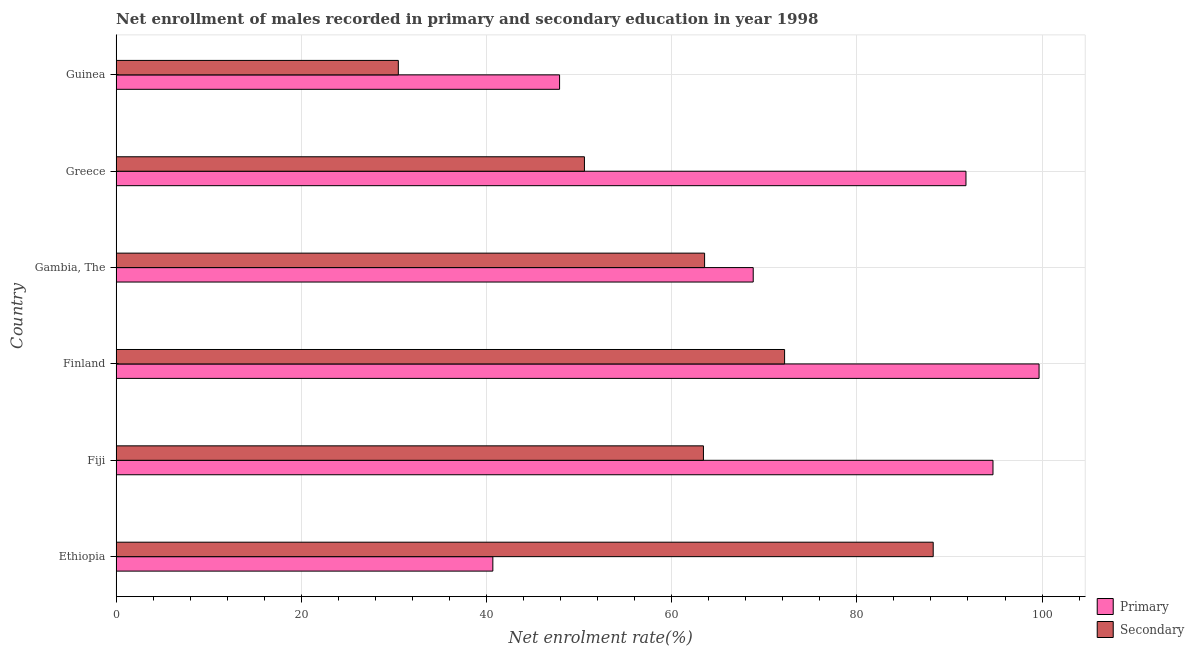How many different coloured bars are there?
Offer a terse response. 2. Are the number of bars on each tick of the Y-axis equal?
Provide a succinct answer. Yes. What is the label of the 4th group of bars from the top?
Provide a succinct answer. Finland. What is the enrollment rate in secondary education in Guinea?
Ensure brevity in your answer.  30.48. Across all countries, what is the maximum enrollment rate in secondary education?
Your response must be concise. 88.24. Across all countries, what is the minimum enrollment rate in secondary education?
Give a very brief answer. 30.48. In which country was the enrollment rate in primary education maximum?
Make the answer very short. Finland. In which country was the enrollment rate in secondary education minimum?
Your answer should be very brief. Guinea. What is the total enrollment rate in secondary education in the graph?
Provide a succinct answer. 368.48. What is the difference between the enrollment rate in primary education in Ethiopia and that in Gambia, The?
Provide a short and direct response. -28.12. What is the difference between the enrollment rate in secondary education in Fiji and the enrollment rate in primary education in Guinea?
Ensure brevity in your answer.  15.54. What is the average enrollment rate in secondary education per country?
Keep it short and to the point. 61.41. What is the difference between the enrollment rate in secondary education and enrollment rate in primary education in Finland?
Provide a succinct answer. -27.48. In how many countries, is the enrollment rate in secondary education greater than 72 %?
Your answer should be very brief. 2. What is the ratio of the enrollment rate in secondary education in Fiji to that in Greece?
Your answer should be compact. 1.25. Is the enrollment rate in primary education in Finland less than that in Greece?
Your response must be concise. No. Is the difference between the enrollment rate in secondary education in Finland and Gambia, The greater than the difference between the enrollment rate in primary education in Finland and Gambia, The?
Offer a terse response. No. What is the difference between the highest and the second highest enrollment rate in primary education?
Provide a short and direct response. 4.98. What is the difference between the highest and the lowest enrollment rate in primary education?
Offer a very short reply. 58.99. In how many countries, is the enrollment rate in secondary education greater than the average enrollment rate in secondary education taken over all countries?
Provide a short and direct response. 4. What does the 2nd bar from the top in Ethiopia represents?
Keep it short and to the point. Primary. What does the 1st bar from the bottom in Gambia, The represents?
Ensure brevity in your answer.  Primary. How many bars are there?
Provide a short and direct response. 12. Are the values on the major ticks of X-axis written in scientific E-notation?
Your answer should be very brief. No. Does the graph contain grids?
Your response must be concise. Yes. How many legend labels are there?
Provide a succinct answer. 2. What is the title of the graph?
Your response must be concise. Net enrollment of males recorded in primary and secondary education in year 1998. Does "Old" appear as one of the legend labels in the graph?
Your answer should be very brief. No. What is the label or title of the X-axis?
Your response must be concise. Net enrolment rate(%). What is the label or title of the Y-axis?
Ensure brevity in your answer.  Country. What is the Net enrolment rate(%) of Primary in Ethiopia?
Your answer should be compact. 40.68. What is the Net enrolment rate(%) in Secondary in Ethiopia?
Your response must be concise. 88.24. What is the Net enrolment rate(%) of Primary in Fiji?
Your answer should be very brief. 94.7. What is the Net enrolment rate(%) in Secondary in Fiji?
Keep it short and to the point. 63.43. What is the Net enrolment rate(%) in Primary in Finland?
Offer a very short reply. 99.68. What is the Net enrolment rate(%) in Secondary in Finland?
Ensure brevity in your answer.  72.19. What is the Net enrolment rate(%) of Primary in Gambia, The?
Give a very brief answer. 68.81. What is the Net enrolment rate(%) in Secondary in Gambia, The?
Keep it short and to the point. 63.55. What is the Net enrolment rate(%) of Primary in Greece?
Give a very brief answer. 91.78. What is the Net enrolment rate(%) in Secondary in Greece?
Provide a short and direct response. 50.58. What is the Net enrolment rate(%) of Primary in Guinea?
Give a very brief answer. 47.89. What is the Net enrolment rate(%) in Secondary in Guinea?
Your answer should be very brief. 30.48. Across all countries, what is the maximum Net enrolment rate(%) in Primary?
Offer a very short reply. 99.68. Across all countries, what is the maximum Net enrolment rate(%) in Secondary?
Provide a short and direct response. 88.24. Across all countries, what is the minimum Net enrolment rate(%) in Primary?
Offer a very short reply. 40.68. Across all countries, what is the minimum Net enrolment rate(%) in Secondary?
Provide a succinct answer. 30.48. What is the total Net enrolment rate(%) of Primary in the graph?
Provide a short and direct response. 443.54. What is the total Net enrolment rate(%) of Secondary in the graph?
Provide a short and direct response. 368.48. What is the difference between the Net enrolment rate(%) in Primary in Ethiopia and that in Fiji?
Provide a short and direct response. -54.02. What is the difference between the Net enrolment rate(%) of Secondary in Ethiopia and that in Fiji?
Provide a succinct answer. 24.82. What is the difference between the Net enrolment rate(%) of Primary in Ethiopia and that in Finland?
Your answer should be very brief. -58.99. What is the difference between the Net enrolment rate(%) of Secondary in Ethiopia and that in Finland?
Your response must be concise. 16.05. What is the difference between the Net enrolment rate(%) in Primary in Ethiopia and that in Gambia, The?
Offer a very short reply. -28.12. What is the difference between the Net enrolment rate(%) of Secondary in Ethiopia and that in Gambia, The?
Offer a very short reply. 24.69. What is the difference between the Net enrolment rate(%) in Primary in Ethiopia and that in Greece?
Offer a very short reply. -51.1. What is the difference between the Net enrolment rate(%) of Secondary in Ethiopia and that in Greece?
Your answer should be very brief. 37.67. What is the difference between the Net enrolment rate(%) in Primary in Ethiopia and that in Guinea?
Your answer should be compact. -7.21. What is the difference between the Net enrolment rate(%) of Secondary in Ethiopia and that in Guinea?
Your response must be concise. 57.77. What is the difference between the Net enrolment rate(%) of Primary in Fiji and that in Finland?
Your response must be concise. -4.98. What is the difference between the Net enrolment rate(%) in Secondary in Fiji and that in Finland?
Ensure brevity in your answer.  -8.76. What is the difference between the Net enrolment rate(%) in Primary in Fiji and that in Gambia, The?
Offer a very short reply. 25.89. What is the difference between the Net enrolment rate(%) of Secondary in Fiji and that in Gambia, The?
Your answer should be very brief. -0.12. What is the difference between the Net enrolment rate(%) in Primary in Fiji and that in Greece?
Offer a terse response. 2.92. What is the difference between the Net enrolment rate(%) of Secondary in Fiji and that in Greece?
Offer a very short reply. 12.85. What is the difference between the Net enrolment rate(%) of Primary in Fiji and that in Guinea?
Make the answer very short. 46.81. What is the difference between the Net enrolment rate(%) of Secondary in Fiji and that in Guinea?
Your response must be concise. 32.95. What is the difference between the Net enrolment rate(%) in Primary in Finland and that in Gambia, The?
Keep it short and to the point. 30.87. What is the difference between the Net enrolment rate(%) in Secondary in Finland and that in Gambia, The?
Keep it short and to the point. 8.64. What is the difference between the Net enrolment rate(%) of Primary in Finland and that in Greece?
Keep it short and to the point. 7.89. What is the difference between the Net enrolment rate(%) of Secondary in Finland and that in Greece?
Offer a terse response. 21.62. What is the difference between the Net enrolment rate(%) in Primary in Finland and that in Guinea?
Ensure brevity in your answer.  51.78. What is the difference between the Net enrolment rate(%) in Secondary in Finland and that in Guinea?
Give a very brief answer. 41.72. What is the difference between the Net enrolment rate(%) of Primary in Gambia, The and that in Greece?
Keep it short and to the point. -22.98. What is the difference between the Net enrolment rate(%) in Secondary in Gambia, The and that in Greece?
Make the answer very short. 12.98. What is the difference between the Net enrolment rate(%) in Primary in Gambia, The and that in Guinea?
Provide a short and direct response. 20.91. What is the difference between the Net enrolment rate(%) of Secondary in Gambia, The and that in Guinea?
Ensure brevity in your answer.  33.08. What is the difference between the Net enrolment rate(%) in Primary in Greece and that in Guinea?
Provide a short and direct response. 43.89. What is the difference between the Net enrolment rate(%) in Secondary in Greece and that in Guinea?
Provide a succinct answer. 20.1. What is the difference between the Net enrolment rate(%) in Primary in Ethiopia and the Net enrolment rate(%) in Secondary in Fiji?
Offer a very short reply. -22.75. What is the difference between the Net enrolment rate(%) of Primary in Ethiopia and the Net enrolment rate(%) of Secondary in Finland?
Provide a short and direct response. -31.51. What is the difference between the Net enrolment rate(%) of Primary in Ethiopia and the Net enrolment rate(%) of Secondary in Gambia, The?
Provide a succinct answer. -22.87. What is the difference between the Net enrolment rate(%) of Primary in Ethiopia and the Net enrolment rate(%) of Secondary in Greece?
Your answer should be very brief. -9.89. What is the difference between the Net enrolment rate(%) in Primary in Ethiopia and the Net enrolment rate(%) in Secondary in Guinea?
Your answer should be compact. 10.21. What is the difference between the Net enrolment rate(%) in Primary in Fiji and the Net enrolment rate(%) in Secondary in Finland?
Provide a succinct answer. 22.51. What is the difference between the Net enrolment rate(%) of Primary in Fiji and the Net enrolment rate(%) of Secondary in Gambia, The?
Make the answer very short. 31.15. What is the difference between the Net enrolment rate(%) of Primary in Fiji and the Net enrolment rate(%) of Secondary in Greece?
Offer a very short reply. 44.12. What is the difference between the Net enrolment rate(%) in Primary in Fiji and the Net enrolment rate(%) in Secondary in Guinea?
Give a very brief answer. 64.22. What is the difference between the Net enrolment rate(%) in Primary in Finland and the Net enrolment rate(%) in Secondary in Gambia, The?
Make the answer very short. 36.12. What is the difference between the Net enrolment rate(%) in Primary in Finland and the Net enrolment rate(%) in Secondary in Greece?
Give a very brief answer. 49.1. What is the difference between the Net enrolment rate(%) in Primary in Finland and the Net enrolment rate(%) in Secondary in Guinea?
Your answer should be compact. 69.2. What is the difference between the Net enrolment rate(%) of Primary in Gambia, The and the Net enrolment rate(%) of Secondary in Greece?
Provide a short and direct response. 18.23. What is the difference between the Net enrolment rate(%) of Primary in Gambia, The and the Net enrolment rate(%) of Secondary in Guinea?
Provide a succinct answer. 38.33. What is the difference between the Net enrolment rate(%) in Primary in Greece and the Net enrolment rate(%) in Secondary in Guinea?
Make the answer very short. 61.31. What is the average Net enrolment rate(%) in Primary per country?
Offer a terse response. 73.92. What is the average Net enrolment rate(%) in Secondary per country?
Provide a short and direct response. 61.41. What is the difference between the Net enrolment rate(%) of Primary and Net enrolment rate(%) of Secondary in Ethiopia?
Give a very brief answer. -47.56. What is the difference between the Net enrolment rate(%) of Primary and Net enrolment rate(%) of Secondary in Fiji?
Keep it short and to the point. 31.27. What is the difference between the Net enrolment rate(%) of Primary and Net enrolment rate(%) of Secondary in Finland?
Ensure brevity in your answer.  27.48. What is the difference between the Net enrolment rate(%) of Primary and Net enrolment rate(%) of Secondary in Gambia, The?
Offer a terse response. 5.25. What is the difference between the Net enrolment rate(%) in Primary and Net enrolment rate(%) in Secondary in Greece?
Offer a very short reply. 41.21. What is the difference between the Net enrolment rate(%) of Primary and Net enrolment rate(%) of Secondary in Guinea?
Your answer should be compact. 17.42. What is the ratio of the Net enrolment rate(%) of Primary in Ethiopia to that in Fiji?
Ensure brevity in your answer.  0.43. What is the ratio of the Net enrolment rate(%) in Secondary in Ethiopia to that in Fiji?
Your answer should be compact. 1.39. What is the ratio of the Net enrolment rate(%) in Primary in Ethiopia to that in Finland?
Your answer should be compact. 0.41. What is the ratio of the Net enrolment rate(%) in Secondary in Ethiopia to that in Finland?
Offer a terse response. 1.22. What is the ratio of the Net enrolment rate(%) of Primary in Ethiopia to that in Gambia, The?
Offer a very short reply. 0.59. What is the ratio of the Net enrolment rate(%) in Secondary in Ethiopia to that in Gambia, The?
Provide a succinct answer. 1.39. What is the ratio of the Net enrolment rate(%) in Primary in Ethiopia to that in Greece?
Your answer should be very brief. 0.44. What is the ratio of the Net enrolment rate(%) of Secondary in Ethiopia to that in Greece?
Your response must be concise. 1.74. What is the ratio of the Net enrolment rate(%) in Primary in Ethiopia to that in Guinea?
Your answer should be compact. 0.85. What is the ratio of the Net enrolment rate(%) of Secondary in Ethiopia to that in Guinea?
Ensure brevity in your answer.  2.9. What is the ratio of the Net enrolment rate(%) of Primary in Fiji to that in Finland?
Provide a short and direct response. 0.95. What is the ratio of the Net enrolment rate(%) in Secondary in Fiji to that in Finland?
Provide a succinct answer. 0.88. What is the ratio of the Net enrolment rate(%) of Primary in Fiji to that in Gambia, The?
Provide a succinct answer. 1.38. What is the ratio of the Net enrolment rate(%) of Secondary in Fiji to that in Gambia, The?
Give a very brief answer. 1. What is the ratio of the Net enrolment rate(%) in Primary in Fiji to that in Greece?
Offer a very short reply. 1.03. What is the ratio of the Net enrolment rate(%) of Secondary in Fiji to that in Greece?
Give a very brief answer. 1.25. What is the ratio of the Net enrolment rate(%) in Primary in Fiji to that in Guinea?
Make the answer very short. 1.98. What is the ratio of the Net enrolment rate(%) of Secondary in Fiji to that in Guinea?
Keep it short and to the point. 2.08. What is the ratio of the Net enrolment rate(%) in Primary in Finland to that in Gambia, The?
Make the answer very short. 1.45. What is the ratio of the Net enrolment rate(%) of Secondary in Finland to that in Gambia, The?
Ensure brevity in your answer.  1.14. What is the ratio of the Net enrolment rate(%) of Primary in Finland to that in Greece?
Make the answer very short. 1.09. What is the ratio of the Net enrolment rate(%) of Secondary in Finland to that in Greece?
Make the answer very short. 1.43. What is the ratio of the Net enrolment rate(%) of Primary in Finland to that in Guinea?
Give a very brief answer. 2.08. What is the ratio of the Net enrolment rate(%) in Secondary in Finland to that in Guinea?
Your answer should be very brief. 2.37. What is the ratio of the Net enrolment rate(%) in Primary in Gambia, The to that in Greece?
Ensure brevity in your answer.  0.75. What is the ratio of the Net enrolment rate(%) of Secondary in Gambia, The to that in Greece?
Keep it short and to the point. 1.26. What is the ratio of the Net enrolment rate(%) of Primary in Gambia, The to that in Guinea?
Offer a very short reply. 1.44. What is the ratio of the Net enrolment rate(%) of Secondary in Gambia, The to that in Guinea?
Give a very brief answer. 2.09. What is the ratio of the Net enrolment rate(%) of Primary in Greece to that in Guinea?
Make the answer very short. 1.92. What is the ratio of the Net enrolment rate(%) of Secondary in Greece to that in Guinea?
Keep it short and to the point. 1.66. What is the difference between the highest and the second highest Net enrolment rate(%) in Primary?
Ensure brevity in your answer.  4.98. What is the difference between the highest and the second highest Net enrolment rate(%) of Secondary?
Offer a terse response. 16.05. What is the difference between the highest and the lowest Net enrolment rate(%) of Primary?
Your response must be concise. 58.99. What is the difference between the highest and the lowest Net enrolment rate(%) in Secondary?
Your answer should be compact. 57.77. 